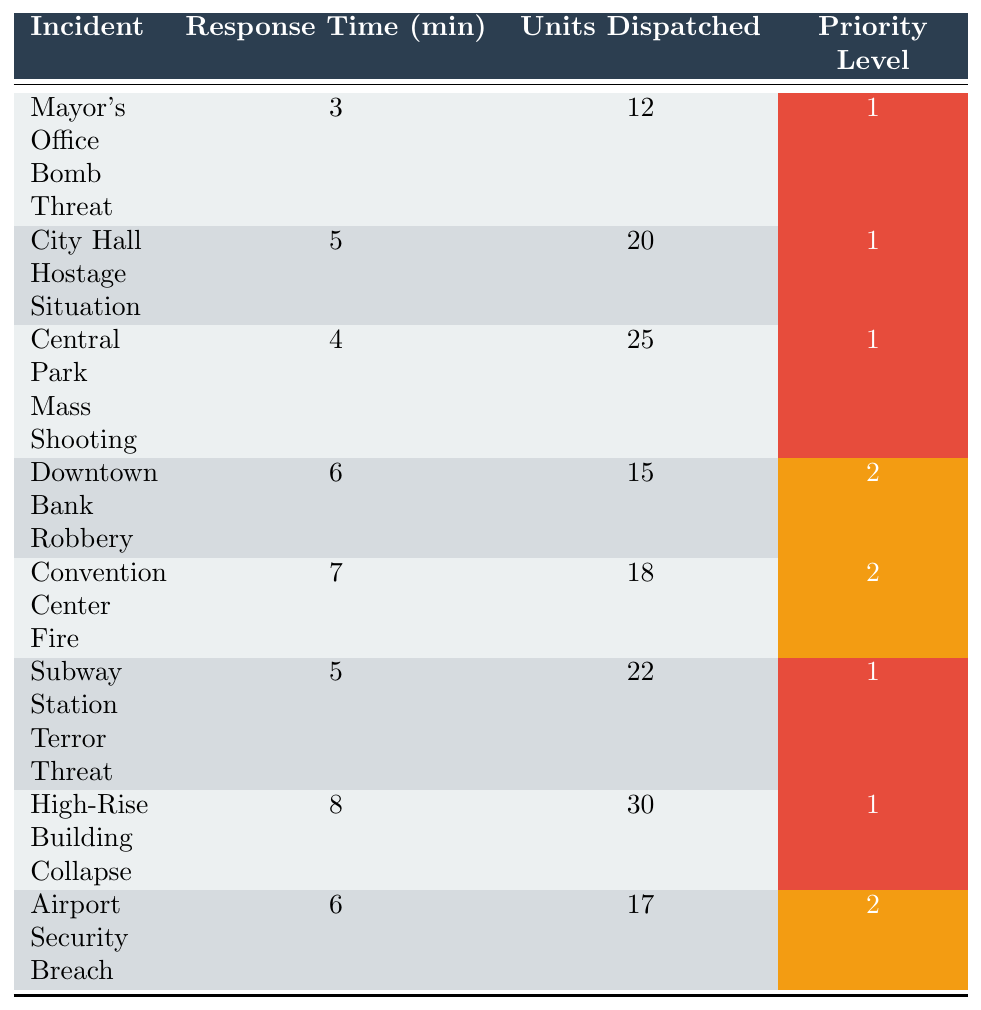What is the response time for the Mayor's Office Bomb Threat? The table lists the incident "Mayor's Office Bomb Threat" and shows a response time of 3 minutes.
Answer: 3 minutes How many units were dispatched for the City Hall Hostage Situation? According to the table, the "City Hall Hostage Situation" had 20 units dispatched.
Answer: 20 units Which incident had the longest response time? The table shows the "High-Rise Building Collapse" with a response time of 8 minutes, which is the highest among all incidents listed.
Answer: High-Rise Building Collapse What is the average response time for priority level 1 incidents? The response times for priority level 1 incidents (3, 5, 4, 5, 8) add up to 25 minutes. There are 5 incidents, so the average response time is 25/5 = 5 minutes.
Answer: 5 minutes Did the Subway Station Terror Threat receive more units than the Downtown Bank Robbery? The table indicates that 22 units were dispatched for the "Subway Station Terror Threat" while 15 units were dispatched for the "Downtown Bank Robbery", therefore, it is true that more units were sent for the Subway incident.
Answer: Yes How many total units were dispatched for all incidents categorized as priority level 2? The incidents categorized as priority level 2 are "Downtown Bank Robbery" (15 units), "Convention Center Fire" (18 units), and "Airport Security Breach" (17 units). Adding these gives a total of 15 + 18 + 17 = 50 units.
Answer: 50 units What is the response time for the incident with the most units dispatched? The incident with the most units dispatched is the "High-Rise Building Collapse" with 30 units. Its response time is 8 minutes, as per the table.
Answer: 8 minutes Are all incidents with a response time greater than 6 minutes assigned to priority level 2? In the table, "High-Rise Building Collapse" has a response time of 8 minutes and is assigned to priority level 1, showing that not all incidents with a response time greater than 6 minutes are priority level 2.
Answer: No How does the response time of the Central Park Mass Shooting compare to the Airport Security Breach? The "Central Park Mass Shooting" has a response time of 4 minutes, while the "Airport Security Breach" has a response time of 6 minutes. Thus, the Central Park incident has a shorter response time.
Answer: Shorter What percentage of the total incidents are classified as priority level 1? There are 8 incidents in total, with 5 classified as priority level 1. The percentage is (5/8) * 100 = 62.5%.
Answer: 62.5% 